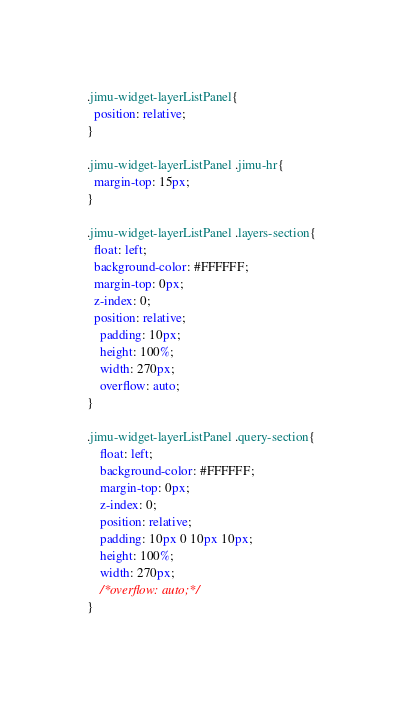<code> <loc_0><loc_0><loc_500><loc_500><_CSS_>
.jimu-widget-layerListPanel{
  position: relative;
}

.jimu-widget-layerListPanel .jimu-hr{
  margin-top: 15px;
}

.jimu-widget-layerListPanel .layers-section{
  float: left;
  background-color: #FFFFFF;
  margin-top: 0px;
  z-index: 0;
  position: relative;
    padding: 10px;
    height: 100%;
    width: 270px;
    overflow: auto;
}

.jimu-widget-layerListPanel .query-section{
    float: left;
    background-color: #FFFFFF;
    margin-top: 0px;
    z-index: 0;
    position: relative;
    padding: 10px 0 10px 10px;
    height: 100%;
    width: 270px;
    /*overflow: auto;*/
}
</code> 